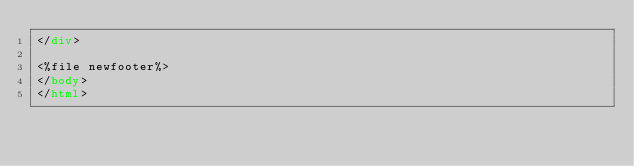<code> <loc_0><loc_0><loc_500><loc_500><_HTML_></div>

<%file newfooter%>
</body>
</html>
</code> 